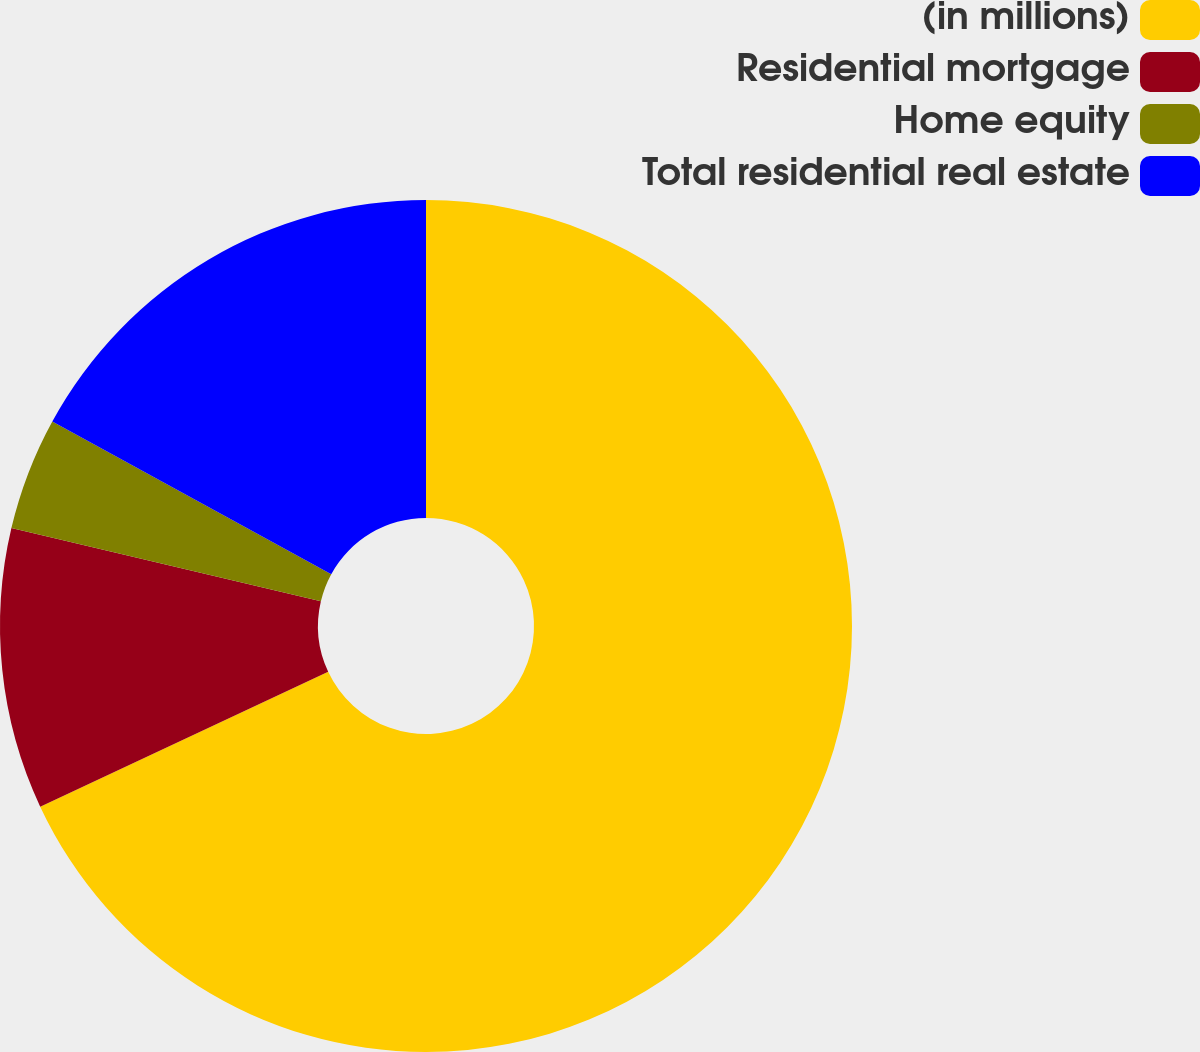Convert chart to OTSL. <chart><loc_0><loc_0><loc_500><loc_500><pie_chart><fcel>(in millions)<fcel>Residential mortgage<fcel>Home equity<fcel>Total residential real estate<nl><fcel>68.03%<fcel>10.66%<fcel>4.28%<fcel>17.03%<nl></chart> 